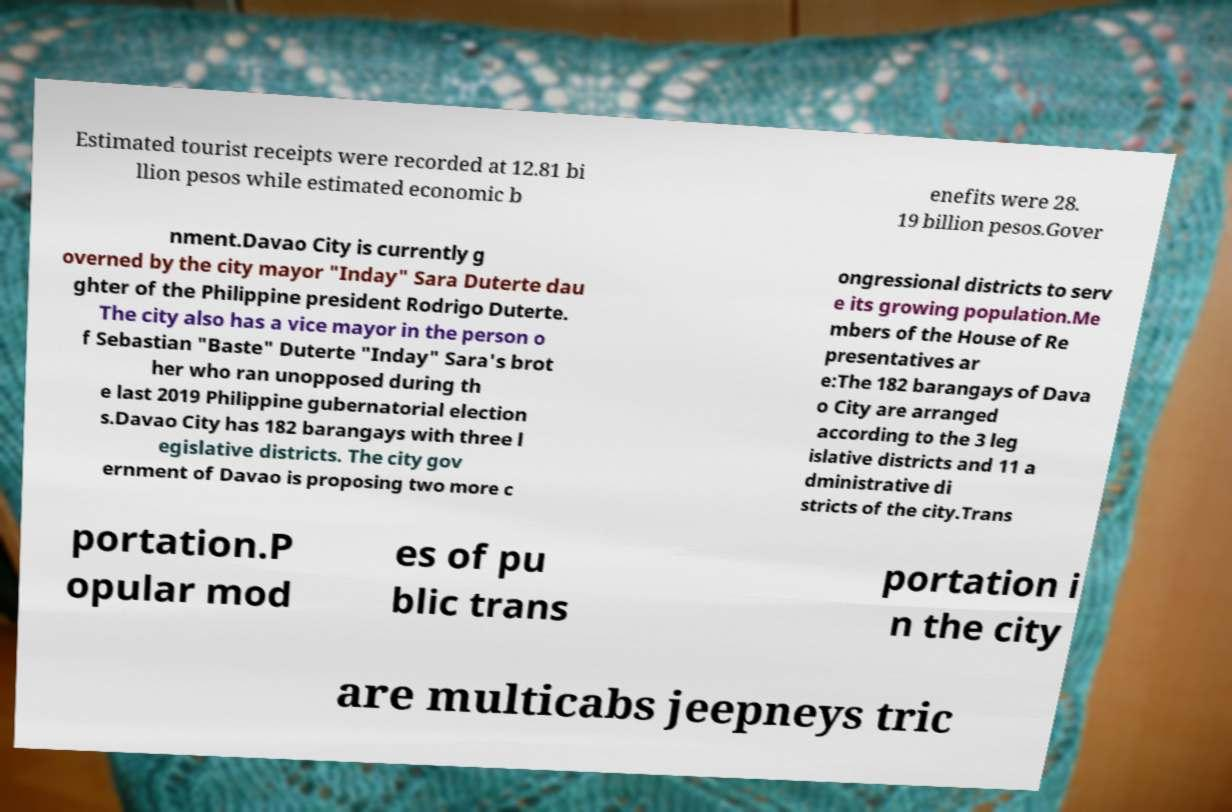Please read and relay the text visible in this image. What does it say? Estimated tourist receipts were recorded at 12.81 bi llion pesos while estimated economic b enefits were 28. 19 billion pesos.Gover nment.Davao City is currently g overned by the city mayor "Inday" Sara Duterte dau ghter of the Philippine president Rodrigo Duterte. The city also has a vice mayor in the person o f Sebastian "Baste" Duterte "Inday" Sara's brot her who ran unopposed during th e last 2019 Philippine gubernatorial election s.Davao City has 182 barangays with three l egislative districts. The city gov ernment of Davao is proposing two more c ongressional districts to serv e its growing population.Me mbers of the House of Re presentatives ar e:The 182 barangays of Dava o City are arranged according to the 3 leg islative districts and 11 a dministrative di stricts of the city.Trans portation.P opular mod es of pu blic trans portation i n the city are multicabs jeepneys tric 